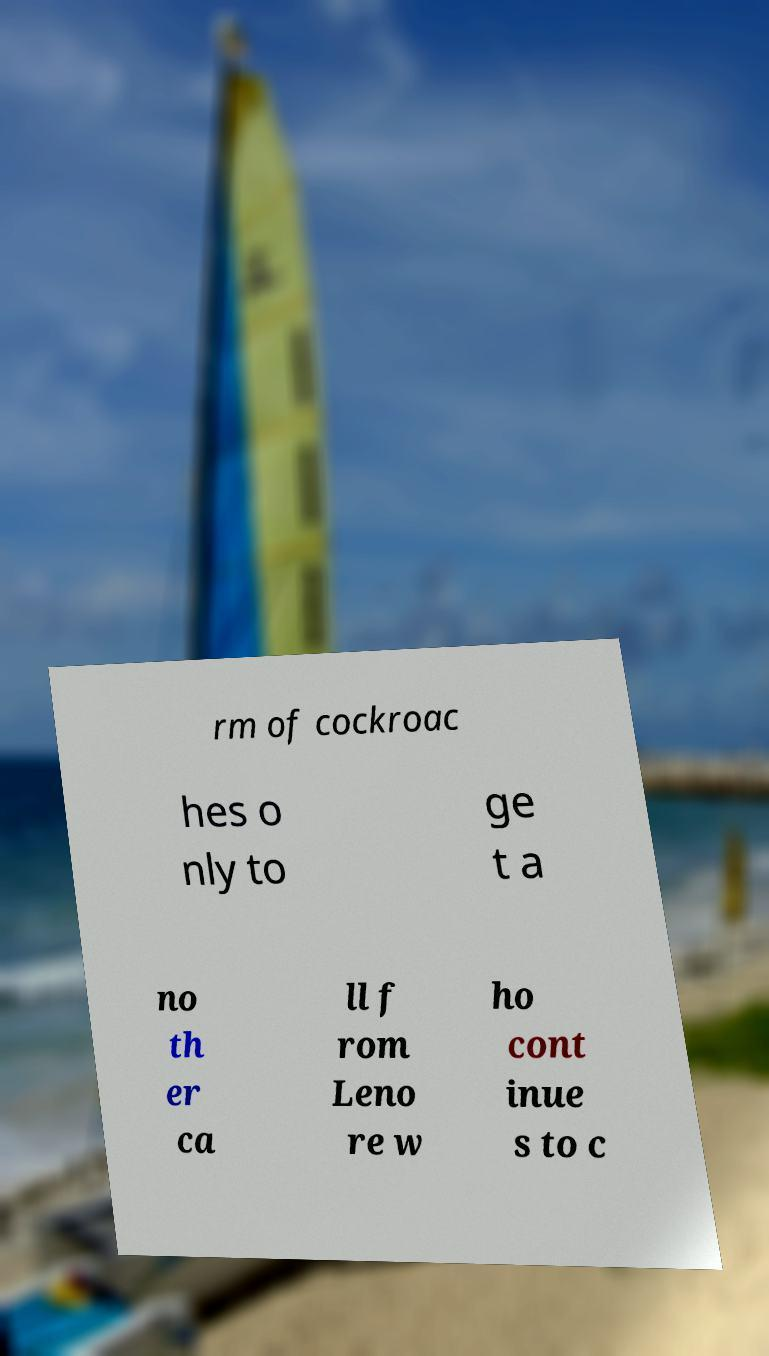Could you extract and type out the text from this image? rm of cockroac hes o nly to ge t a no th er ca ll f rom Leno re w ho cont inue s to c 